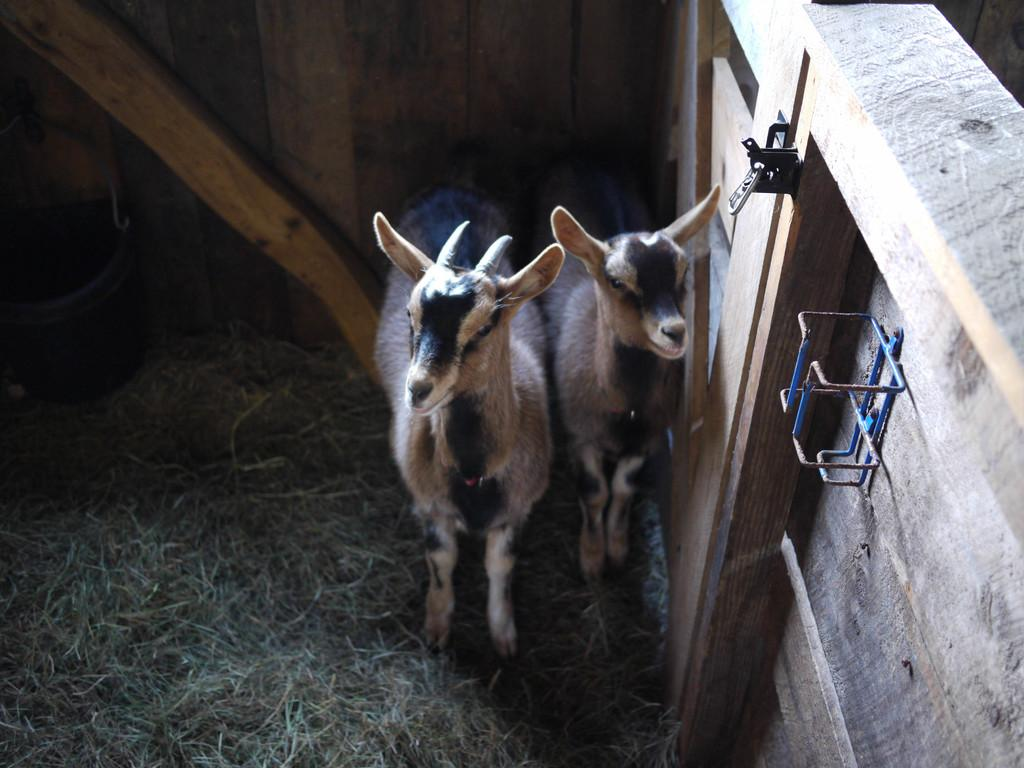How many goats are present in the image? There are two goats in the image. What type of structure can be seen in the image? There is a wooden wall in the image. What type of vegetation is visible in the image? There is grass in the image. How far is the bridge from the goats in the image? There is no bridge present in the image, so it cannot be determined how far it might be from the goats. 